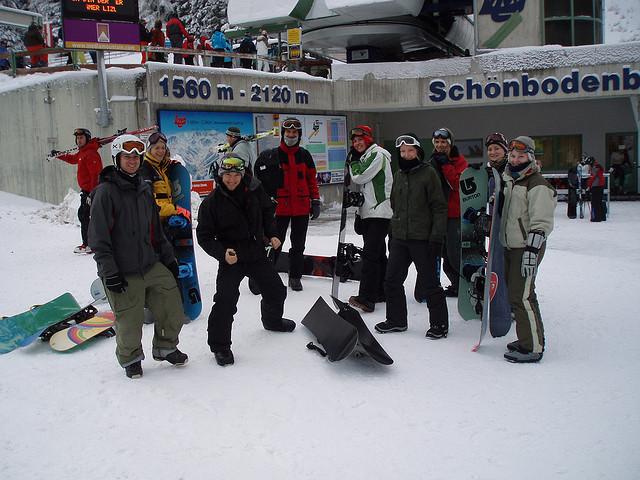Are the people standing on sand?
Quick response, please. No. Is the right ski near the tree?
Give a very brief answer. No. What color jackets are the people primarily wearing?
Write a very short answer. Black. What activity are these people doing?
Give a very brief answer. Snowboarding. What is the name of the mountain?
Keep it brief. Schonbodenb. What kind of building is in the background?
Short answer required. Ski lodge. Is everyone wearing gloves/mittens?
Short answer required. No. Are the children having fun?
Quick response, please. Yes. Where does it say "1560 m"?
Give a very brief answer. Wall. What winter-related activity are the people in the picture doing?
Be succinct. Snowboarding. Is the picture blurry?
Be succinct. No. What activity are these people partaking in?
Answer briefly. Snowboarding. What does the last sign say?
Quick response, please. Schonbodenb. Are the men color coordinated?
Keep it brief. No. What sport do they do?
Give a very brief answer. Snowboarding. What were the people doing?
Keep it brief. Snowboarding. Does the man in the middle have a snowboard?
Write a very short answer. Yes. How many people are actively wearing their goggles?
Give a very brief answer. 0. 